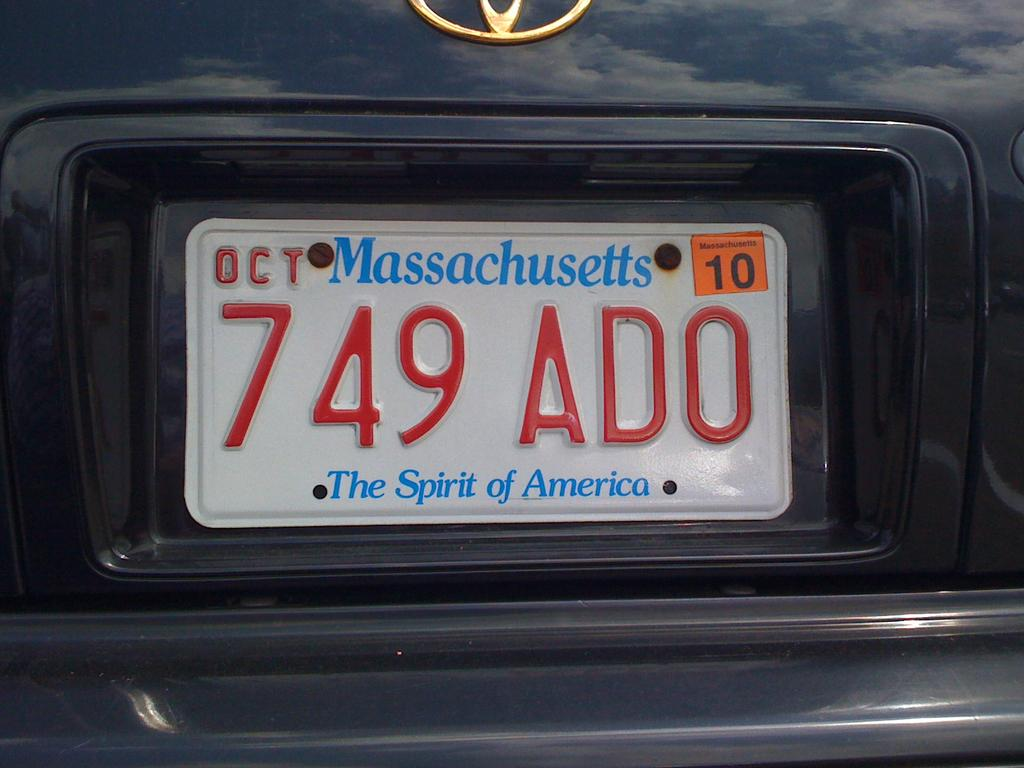<image>
Present a compact description of the photo's key features. Massachusetts license plate which says 749ADO on it. 